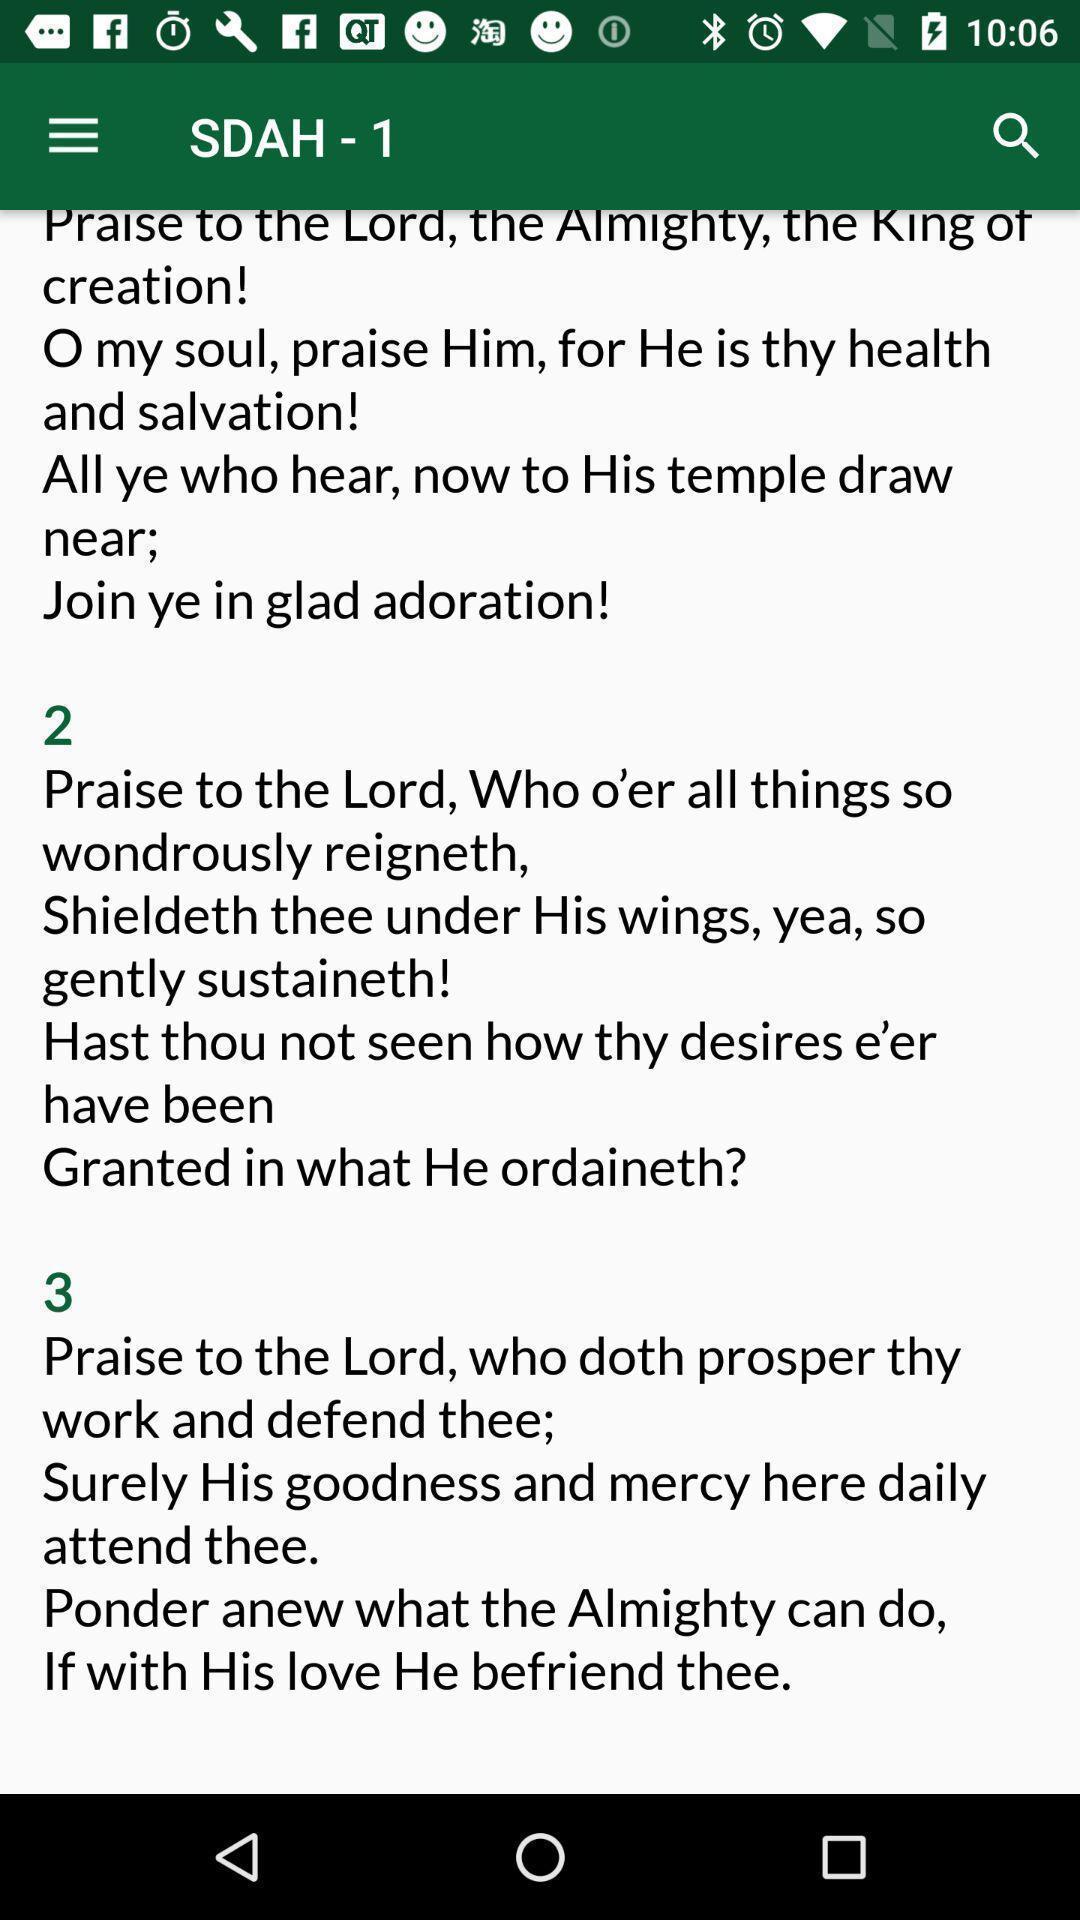Summarize the main components in this picture. Page displaying different holi songs. 